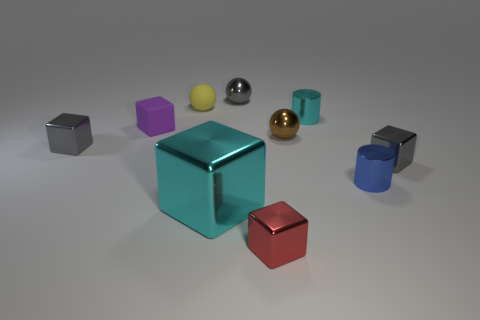Subtract all purple blocks. How many blocks are left? 4 Subtract all yellow blocks. Subtract all green cylinders. How many blocks are left? 5 Subtract all spheres. How many objects are left? 7 Subtract 0 red cylinders. How many objects are left? 10 Subtract all tiny gray spheres. Subtract all tiny gray objects. How many objects are left? 6 Add 8 cyan cylinders. How many cyan cylinders are left? 9 Add 9 big cubes. How many big cubes exist? 10 